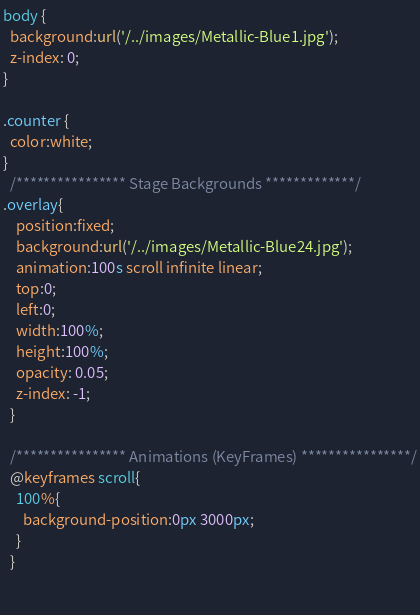<code> <loc_0><loc_0><loc_500><loc_500><_CSS_>body {
  background:url('/../images/Metallic-Blue1.jpg');
  z-index: 0;
}

.counter {
  color:white;
}
  /**************** Stage Backgrounds *************/
.overlay{
    position:fixed;
    background:url('/../images/Metallic-Blue24.jpg');
    animation:100s scroll infinite linear;
    top:0;
    left:0;
    width:100%;
    height:100%;
    opacity: 0.05;
    z-index: -1;
  }

  /**************** Animations (KeyFrames) ****************/
  @keyframes scroll{
    100%{
      background-position:0px 3000px;
    }
  }
  
  </code> 